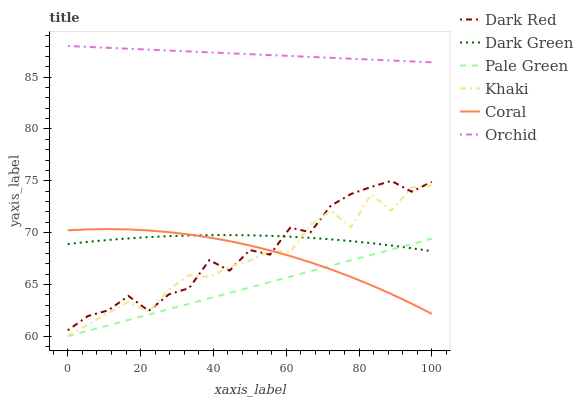Does Pale Green have the minimum area under the curve?
Answer yes or no. Yes. Does Orchid have the maximum area under the curve?
Answer yes or no. Yes. Does Dark Red have the minimum area under the curve?
Answer yes or no. No. Does Dark Red have the maximum area under the curve?
Answer yes or no. No. Is Pale Green the smoothest?
Answer yes or no. Yes. Is Dark Red the roughest?
Answer yes or no. Yes. Is Coral the smoothest?
Answer yes or no. No. Is Coral the roughest?
Answer yes or no. No. Does Khaki have the lowest value?
Answer yes or no. Yes. Does Dark Red have the lowest value?
Answer yes or no. No. Does Orchid have the highest value?
Answer yes or no. Yes. Does Dark Red have the highest value?
Answer yes or no. No. Is Pale Green less than Dark Red?
Answer yes or no. Yes. Is Orchid greater than Coral?
Answer yes or no. Yes. Does Pale Green intersect Khaki?
Answer yes or no. Yes. Is Pale Green less than Khaki?
Answer yes or no. No. Is Pale Green greater than Khaki?
Answer yes or no. No. Does Pale Green intersect Dark Red?
Answer yes or no. No. 